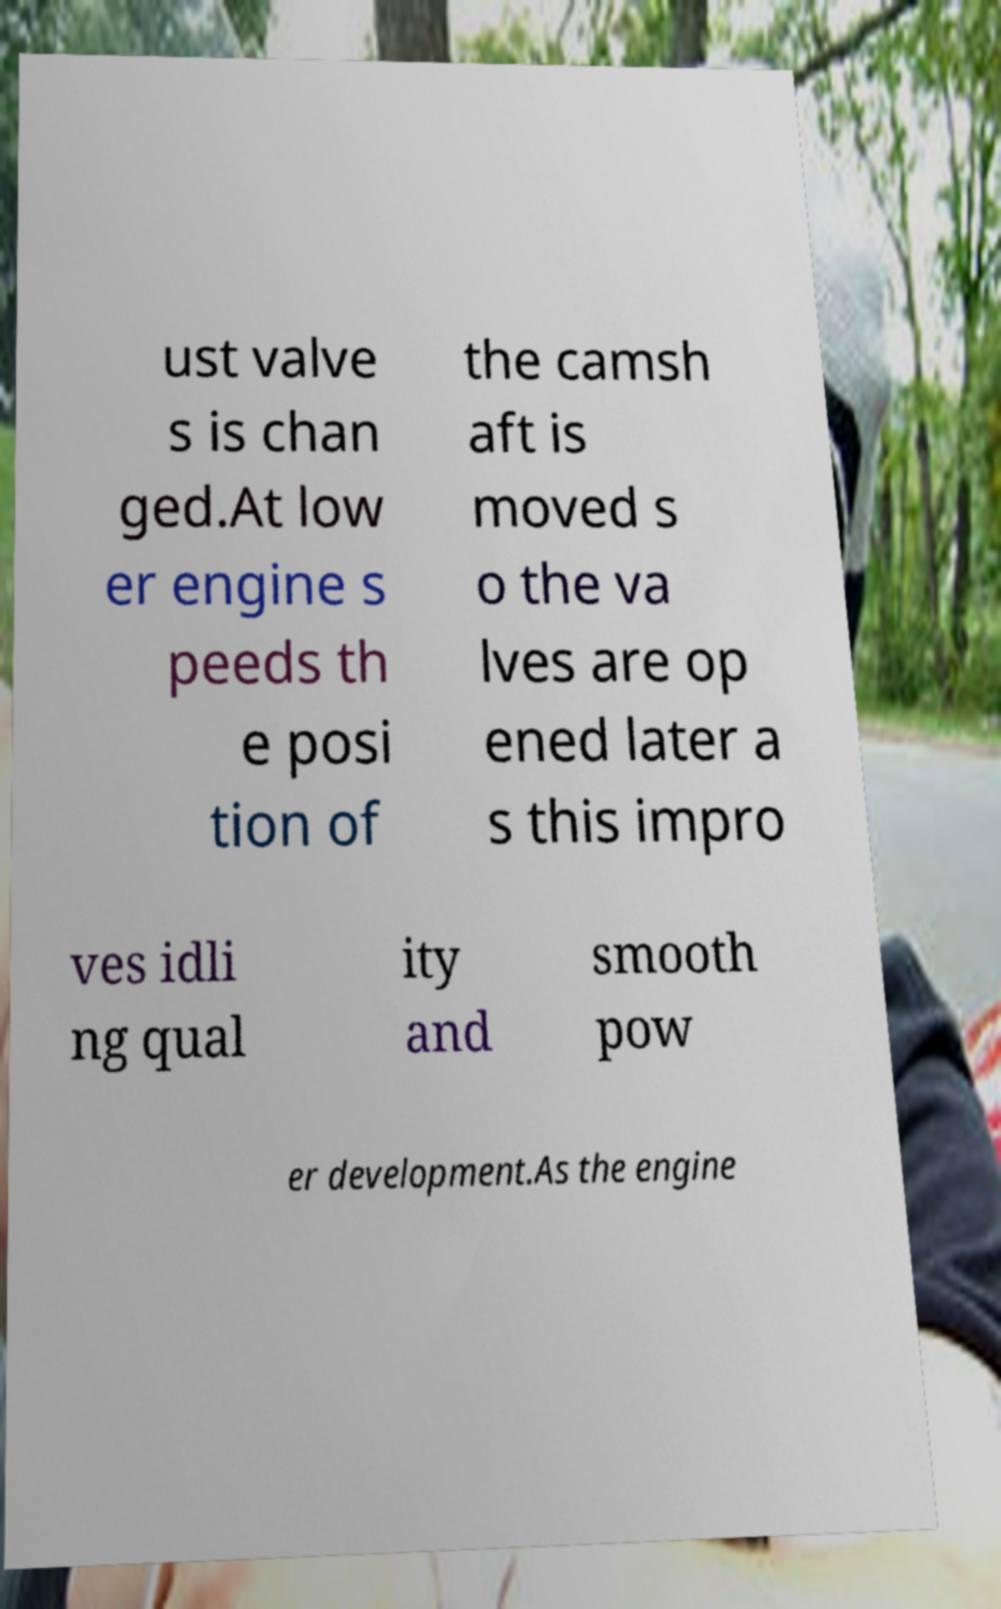Please read and relay the text visible in this image. What does it say? ust valve s is chan ged.At low er engine s peeds th e posi tion of the camsh aft is moved s o the va lves are op ened later a s this impro ves idli ng qual ity and smooth pow er development.As the engine 